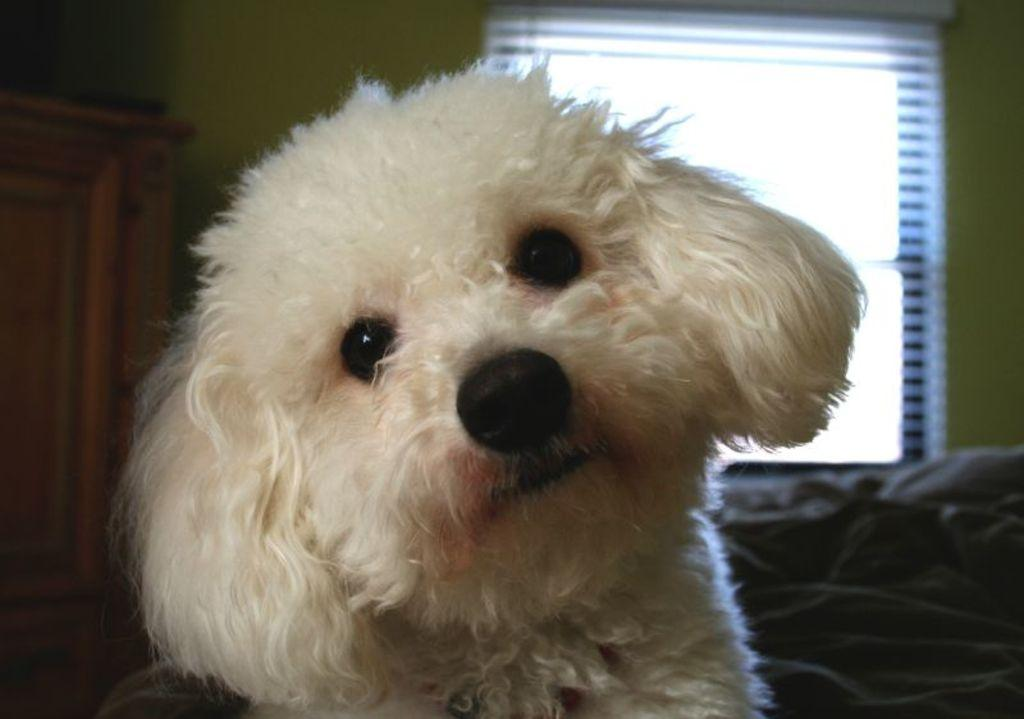What type of animal is in the picture? There is a white-colored dog in the picture. What is on the window in the picture? There are blinds on a window in the picture. What can be seen on the left side of the image? There appears to be a cupboard on the left side of the image. Can you describe the possible furniture behind the dog? There might be a sofa visible behind the dog. What type of cactus is present in the image? There is no cactus present in the image. What decision is the dog making in the image? The dog is not making any decisions in the image; it is simply sitting or standing. 